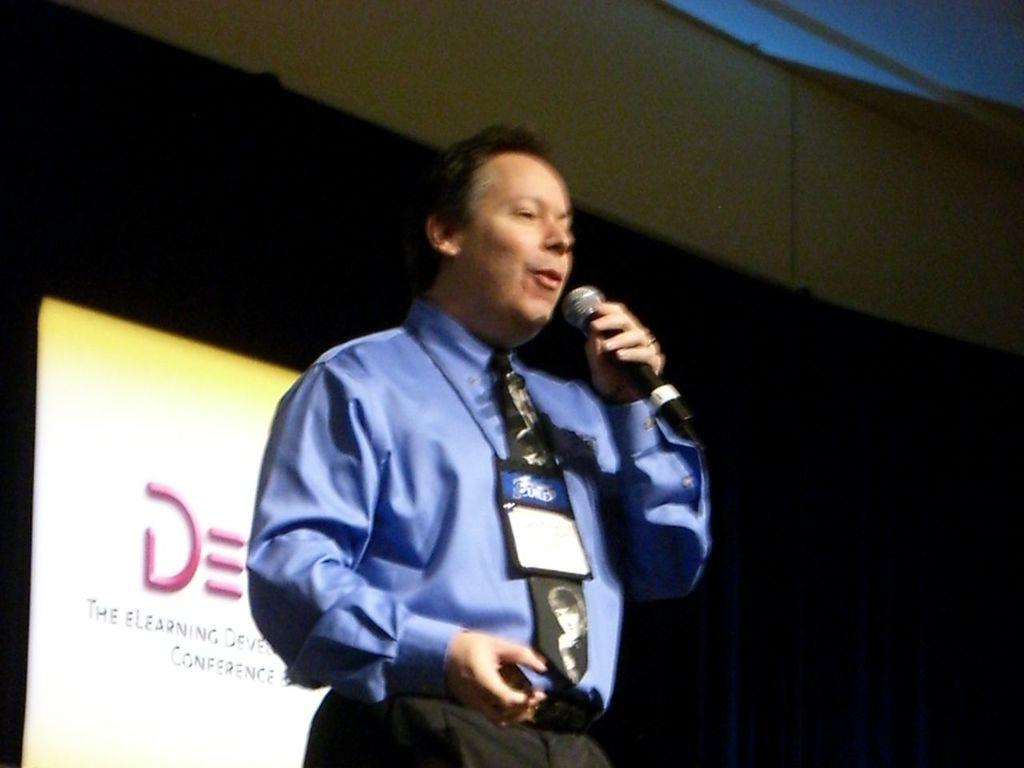What is the main subject of the image? There is a person in the image. What is the person doing in the image? The person is standing in the image. What object is the person holding in the image? The person is holding a microphone in the image. What can be seen on the person's clothing in the image? The person is wearing an ID card in the image. What type of insect is crawling on the person's shoulder in the image? There is no insect visible on the person's shoulder in the image. 